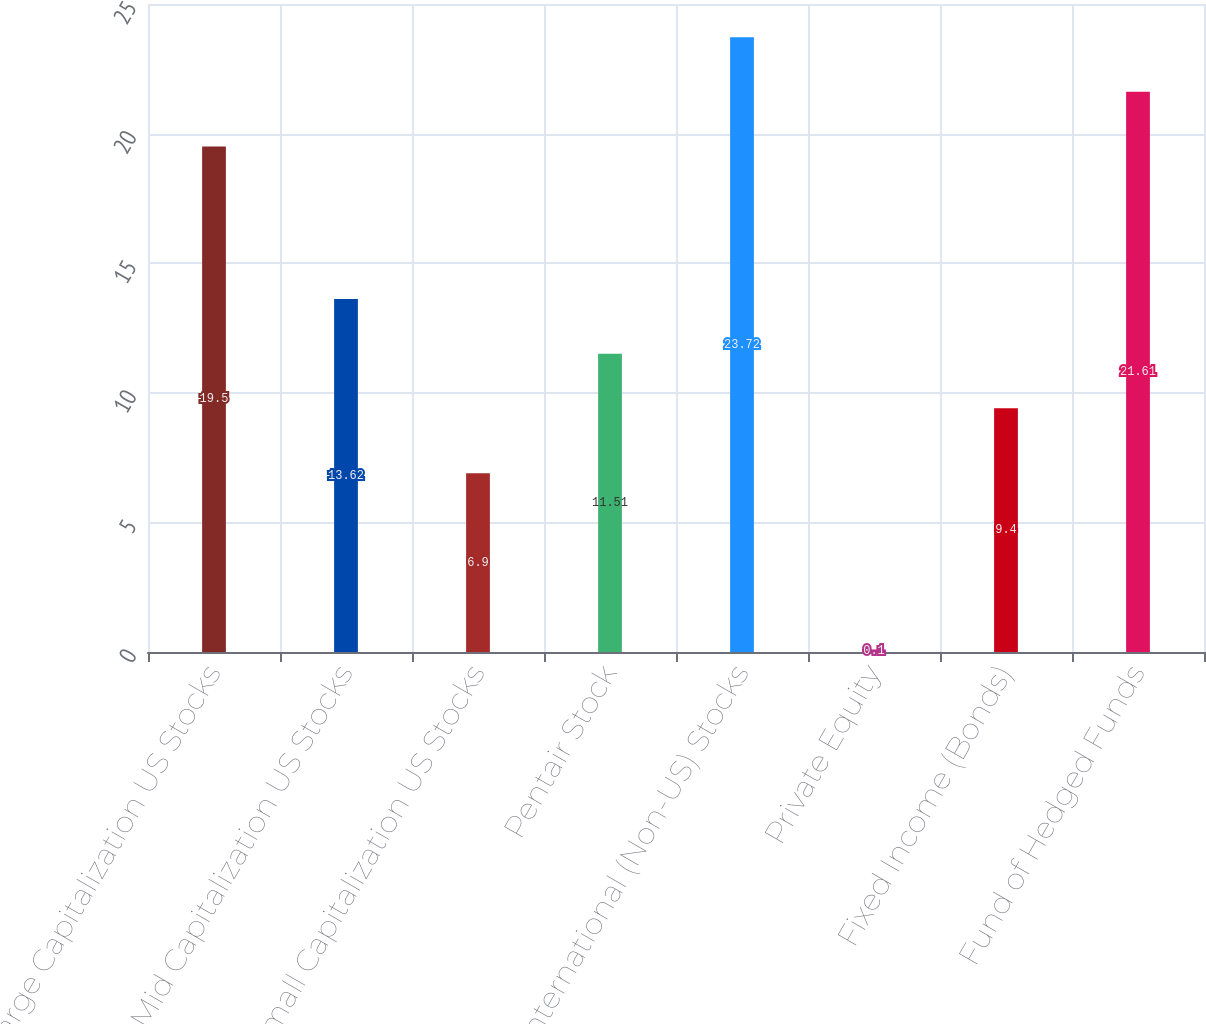<chart> <loc_0><loc_0><loc_500><loc_500><bar_chart><fcel>Large Capitalization US Stocks<fcel>Mid Capitalization US Stocks<fcel>Small Capitalization US Stocks<fcel>Pentair Stock<fcel>International (Non-US) Stocks<fcel>Private Equity<fcel>Fixed Income (Bonds)<fcel>Fund of Hedged Funds<nl><fcel>19.5<fcel>13.62<fcel>6.9<fcel>11.51<fcel>23.72<fcel>0.1<fcel>9.4<fcel>21.61<nl></chart> 